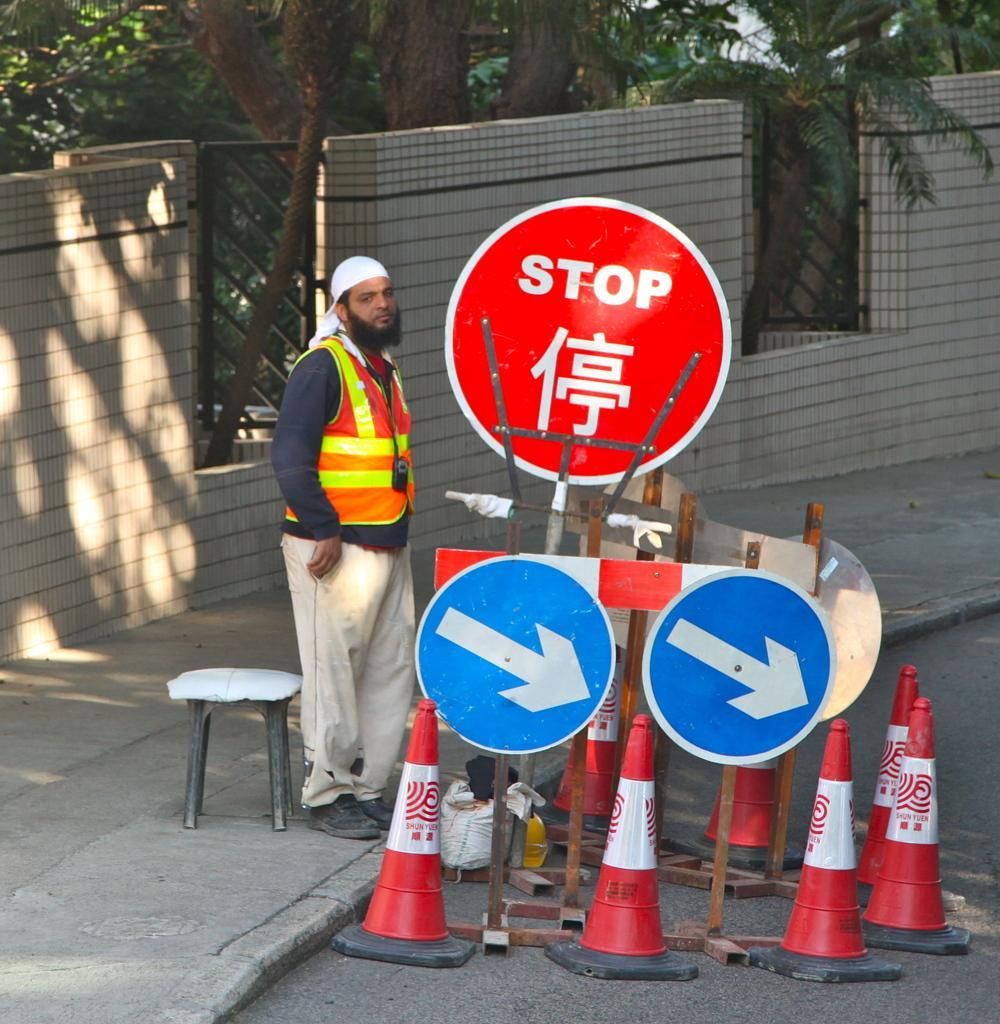How would you summarize this image in a sentence or two? In this picture I can observe traffic cones and red color board in the middle of the picture. On the left side I can observe a person standing on the land. In the background I can observe wall and some trees. 